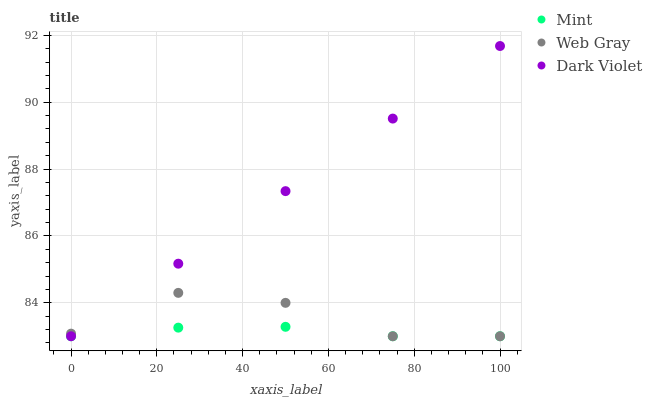Does Mint have the minimum area under the curve?
Answer yes or no. Yes. Does Dark Violet have the maximum area under the curve?
Answer yes or no. Yes. Does Dark Violet have the minimum area under the curve?
Answer yes or no. No. Does Mint have the maximum area under the curve?
Answer yes or no. No. Is Dark Violet the smoothest?
Answer yes or no. Yes. Is Web Gray the roughest?
Answer yes or no. Yes. Is Mint the smoothest?
Answer yes or no. No. Is Mint the roughest?
Answer yes or no. No. Does Web Gray have the lowest value?
Answer yes or no. Yes. Does Dark Violet have the highest value?
Answer yes or no. Yes. Does Mint have the highest value?
Answer yes or no. No. Does Mint intersect Dark Violet?
Answer yes or no. Yes. Is Mint less than Dark Violet?
Answer yes or no. No. Is Mint greater than Dark Violet?
Answer yes or no. No. 